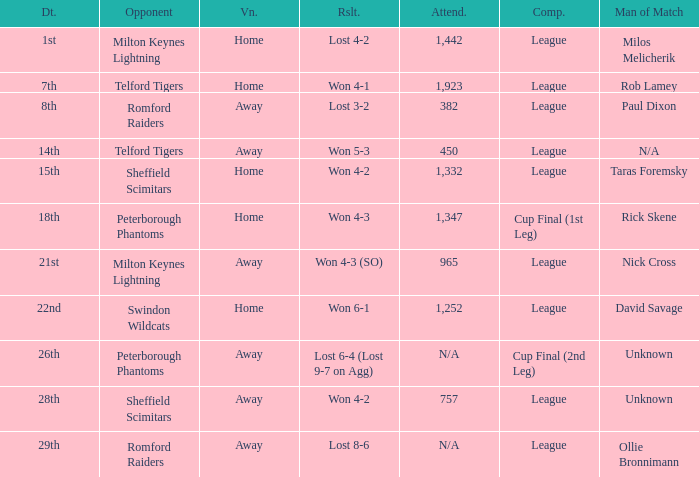What competition was held on the 26th? Cup Final (2nd Leg). 